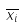<formula> <loc_0><loc_0><loc_500><loc_500>\overline { x _ { i } }</formula> 